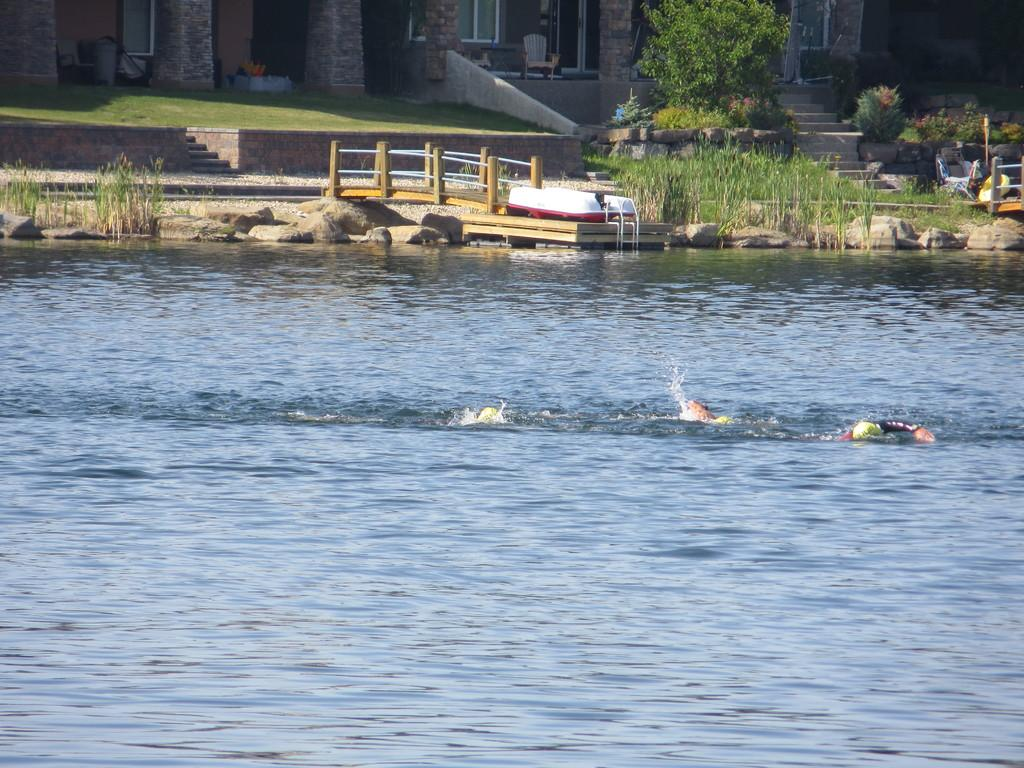What type of natural feature is present in the image? There is a river in the image. What can be seen in the background of the image? There are plants and a house in the background of the image. What type of class is being held near the river in the image? There is no class or any indication of a class being held in the image. 